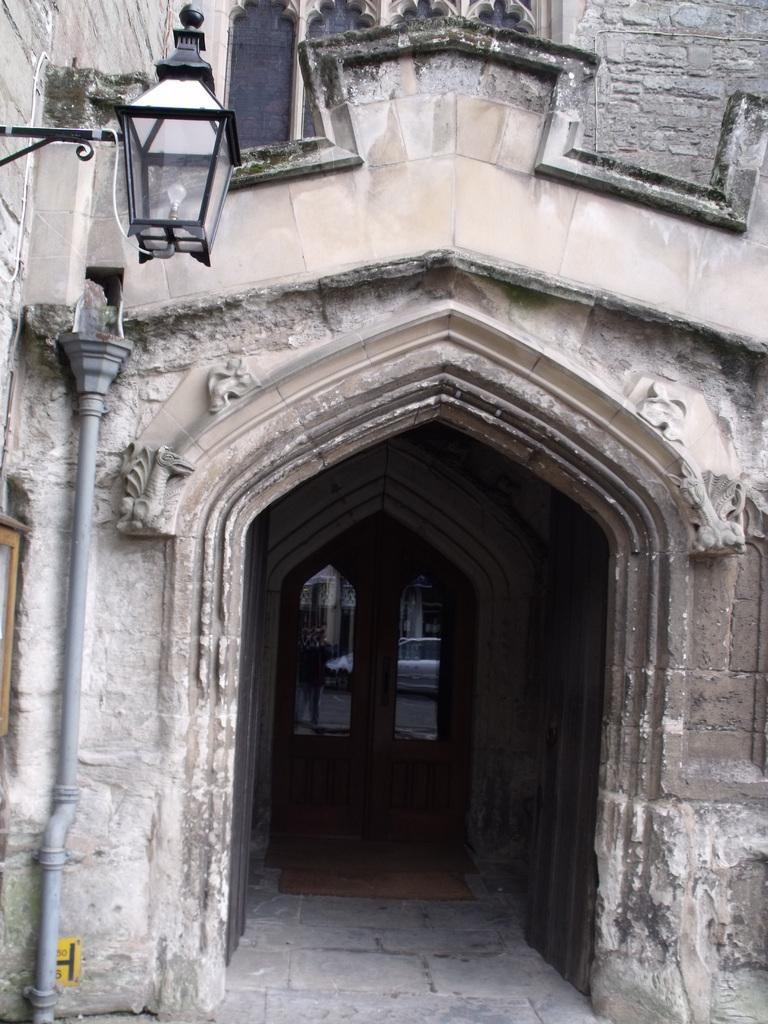Please provide a concise description of this image. In the picture we can see the old building part with a wooden door and on the wall of the building we can see a lamp and beside it we can see a pipe. 